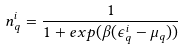Convert formula to latex. <formula><loc_0><loc_0><loc_500><loc_500>n _ { q } ^ { i } = \frac { 1 } { 1 + e x p ( \beta ( \epsilon _ { q } ^ { i } - \mu _ { q } ) ) }</formula> 